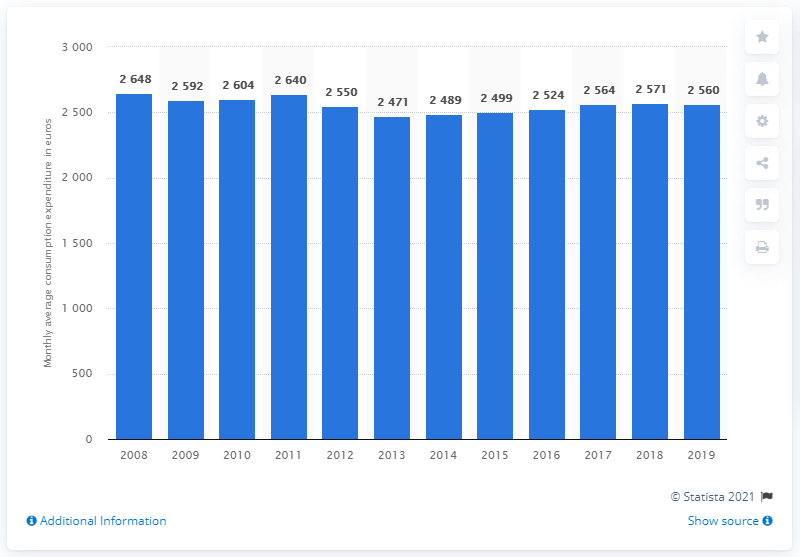List a handful of essential elements in this visual. In 2013, the lowest consumption expenditure in Italy was recorded. 